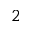<formula> <loc_0><loc_0><loc_500><loc_500>2</formula> 